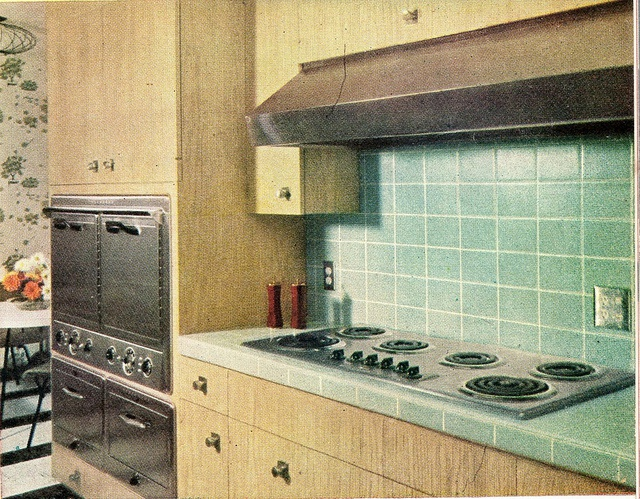Describe the objects in this image and their specific colors. I can see oven in khaki, gray, and black tones, oven in khaki, darkgray, gray, black, and beige tones, chair in khaki, black, gray, darkgray, and lightgray tones, dining table in khaki, lightgray, tan, and gray tones, and vase in khaki, tan, and gray tones in this image. 